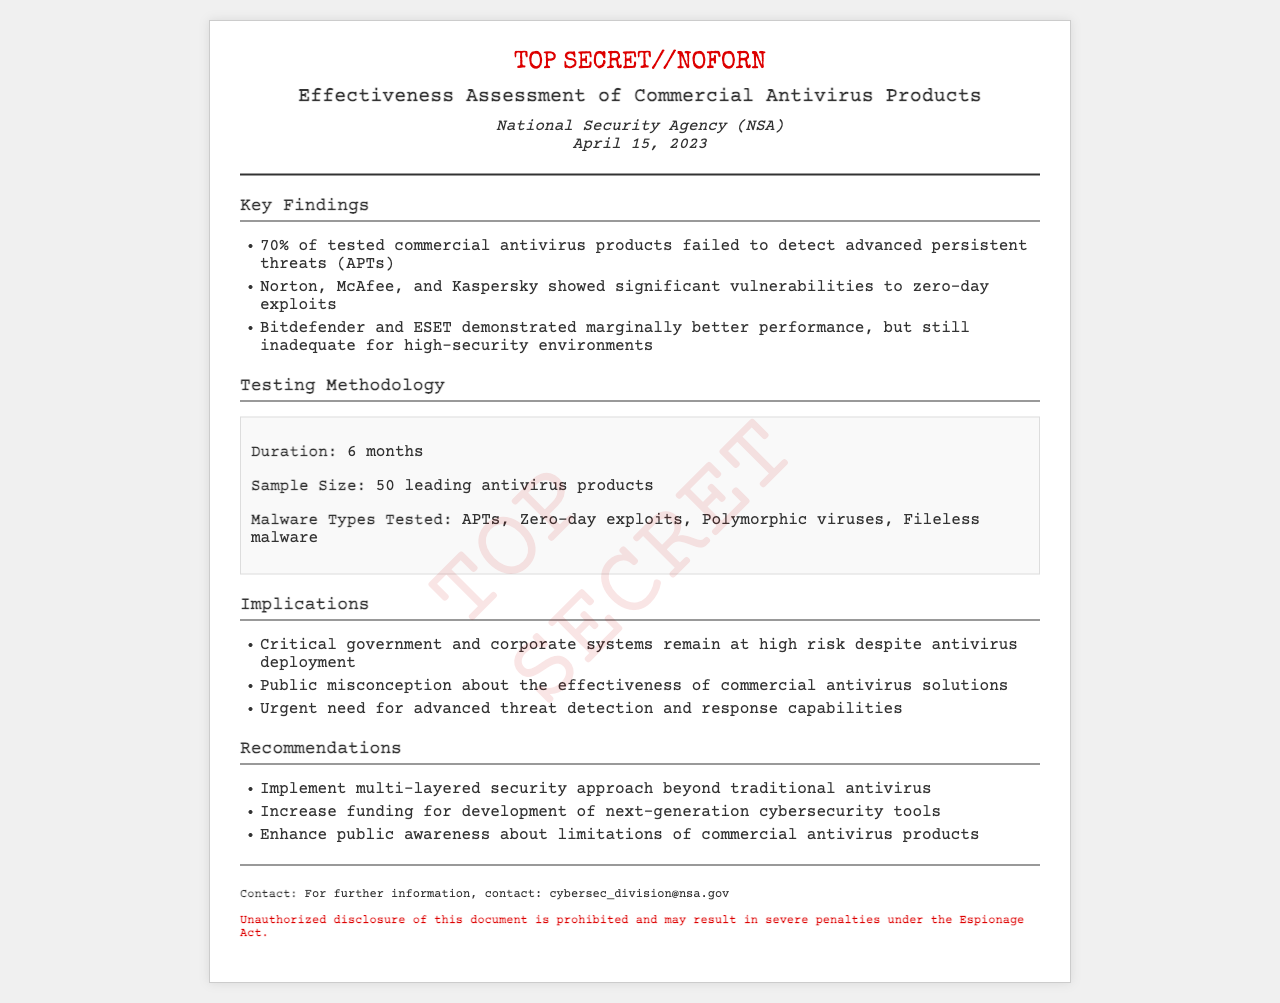What agency conducted the assessment? The assessment was conducted by the National Security Agency (NSA), as stated in the document.
Answer: National Security Agency (NSA) What was the date of the findings? The document specifies the date as April 15, 2023.
Answer: April 15, 2023 What percentage of products failed to detect APTs? The document states that 70% of tested commercial antivirus products failed to detect APTs.
Answer: 70% Which antivirus products showed significant vulnerabilities to zero-day exploits? The document lists Norton, McAfee, and Kaspersky as those that showed significant vulnerabilities.
Answer: Norton, McAfee, Kaspersky How long did the testing last? The document indicates that the testing duration was 6 months.
Answer: 6 months What types of malware were tested? The document outlines the types of malware tested including APTs, zero-day exploits, polymorphic viruses, and fileless malware.
Answer: APTs, zero-day exploits, polymorphic viruses, fileless malware What is one recommendation given in the document? The recommendations section includes implementing a multi-layered security approach beyond traditional antivirus.
Answer: Implement multi-layered security approach What classification is associated with this document? The document is classified as TOP SECRET//NOFORN.
Answer: TOP SECRET//NOFORN What are the implications of the findings? One implication listed is that critical government and corporate systems remain at high risk despite antivirus deployment.
Answer: High risk despite antivirus deployment 